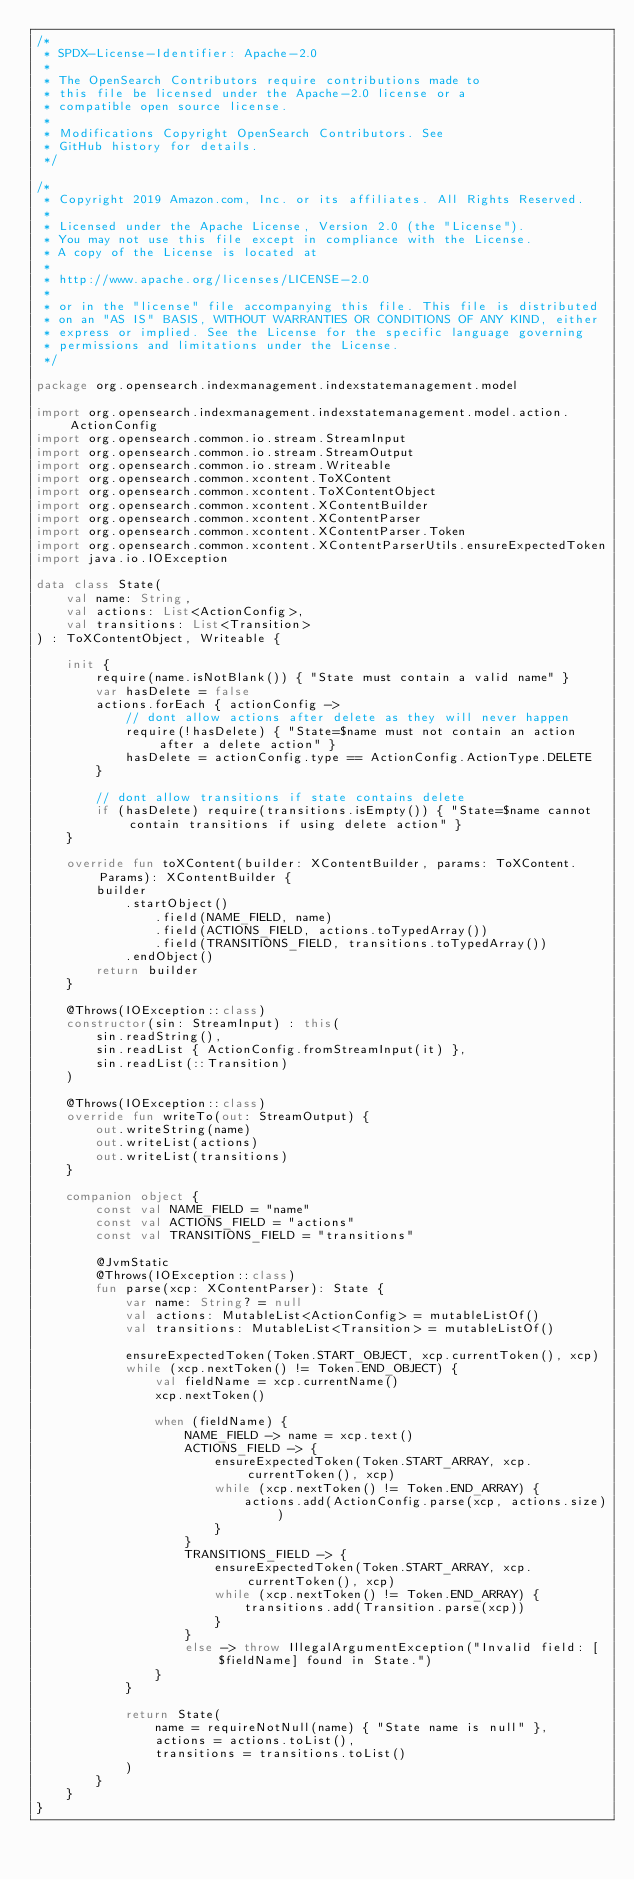<code> <loc_0><loc_0><loc_500><loc_500><_Kotlin_>/*
 * SPDX-License-Identifier: Apache-2.0
 *
 * The OpenSearch Contributors require contributions made to
 * this file be licensed under the Apache-2.0 license or a
 * compatible open source license.
 *
 * Modifications Copyright OpenSearch Contributors. See
 * GitHub history for details.
 */

/*
 * Copyright 2019 Amazon.com, Inc. or its affiliates. All Rights Reserved.
 *
 * Licensed under the Apache License, Version 2.0 (the "License").
 * You may not use this file except in compliance with the License.
 * A copy of the License is located at
 *
 * http://www.apache.org/licenses/LICENSE-2.0
 *
 * or in the "license" file accompanying this file. This file is distributed
 * on an "AS IS" BASIS, WITHOUT WARRANTIES OR CONDITIONS OF ANY KIND, either
 * express or implied. See the License for the specific language governing
 * permissions and limitations under the License.
 */

package org.opensearch.indexmanagement.indexstatemanagement.model

import org.opensearch.indexmanagement.indexstatemanagement.model.action.ActionConfig
import org.opensearch.common.io.stream.StreamInput
import org.opensearch.common.io.stream.StreamOutput
import org.opensearch.common.io.stream.Writeable
import org.opensearch.common.xcontent.ToXContent
import org.opensearch.common.xcontent.ToXContentObject
import org.opensearch.common.xcontent.XContentBuilder
import org.opensearch.common.xcontent.XContentParser
import org.opensearch.common.xcontent.XContentParser.Token
import org.opensearch.common.xcontent.XContentParserUtils.ensureExpectedToken
import java.io.IOException

data class State(
    val name: String,
    val actions: List<ActionConfig>,
    val transitions: List<Transition>
) : ToXContentObject, Writeable {

    init {
        require(name.isNotBlank()) { "State must contain a valid name" }
        var hasDelete = false
        actions.forEach { actionConfig ->
            // dont allow actions after delete as they will never happen
            require(!hasDelete) { "State=$name must not contain an action after a delete action" }
            hasDelete = actionConfig.type == ActionConfig.ActionType.DELETE
        }

        // dont allow transitions if state contains delete
        if (hasDelete) require(transitions.isEmpty()) { "State=$name cannot contain transitions if using delete action" }
    }

    override fun toXContent(builder: XContentBuilder, params: ToXContent.Params): XContentBuilder {
        builder
            .startObject()
                .field(NAME_FIELD, name)
                .field(ACTIONS_FIELD, actions.toTypedArray())
                .field(TRANSITIONS_FIELD, transitions.toTypedArray())
            .endObject()
        return builder
    }

    @Throws(IOException::class)
    constructor(sin: StreamInput) : this(
        sin.readString(),
        sin.readList { ActionConfig.fromStreamInput(it) },
        sin.readList(::Transition)
    )

    @Throws(IOException::class)
    override fun writeTo(out: StreamOutput) {
        out.writeString(name)
        out.writeList(actions)
        out.writeList(transitions)
    }

    companion object {
        const val NAME_FIELD = "name"
        const val ACTIONS_FIELD = "actions"
        const val TRANSITIONS_FIELD = "transitions"

        @JvmStatic
        @Throws(IOException::class)
        fun parse(xcp: XContentParser): State {
            var name: String? = null
            val actions: MutableList<ActionConfig> = mutableListOf()
            val transitions: MutableList<Transition> = mutableListOf()

            ensureExpectedToken(Token.START_OBJECT, xcp.currentToken(), xcp)
            while (xcp.nextToken() != Token.END_OBJECT) {
                val fieldName = xcp.currentName()
                xcp.nextToken()

                when (fieldName) {
                    NAME_FIELD -> name = xcp.text()
                    ACTIONS_FIELD -> {
                        ensureExpectedToken(Token.START_ARRAY, xcp.currentToken(), xcp)
                        while (xcp.nextToken() != Token.END_ARRAY) {
                            actions.add(ActionConfig.parse(xcp, actions.size))
                        }
                    }
                    TRANSITIONS_FIELD -> {
                        ensureExpectedToken(Token.START_ARRAY, xcp.currentToken(), xcp)
                        while (xcp.nextToken() != Token.END_ARRAY) {
                            transitions.add(Transition.parse(xcp))
                        }
                    }
                    else -> throw IllegalArgumentException("Invalid field: [$fieldName] found in State.")
                }
            }

            return State(
                name = requireNotNull(name) { "State name is null" },
                actions = actions.toList(),
                transitions = transitions.toList()
            )
        }
    }
}
</code> 